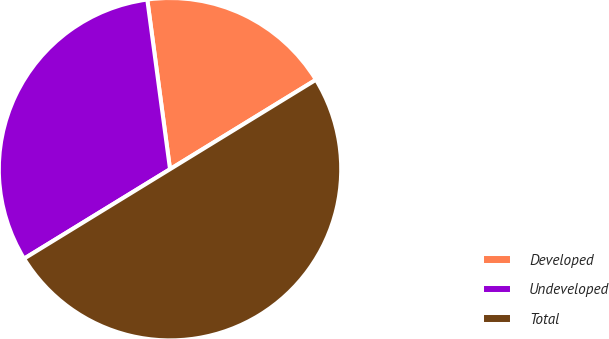Convert chart. <chart><loc_0><loc_0><loc_500><loc_500><pie_chart><fcel>Developed<fcel>Undeveloped<fcel>Total<nl><fcel>18.37%<fcel>31.63%<fcel>50.0%<nl></chart> 